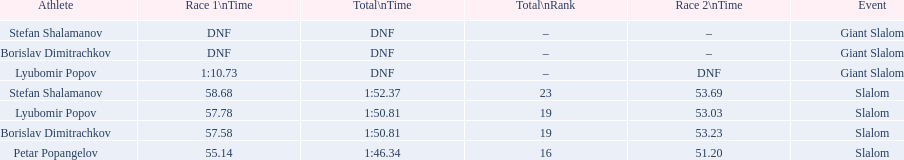How many athletes are there total? 4. 